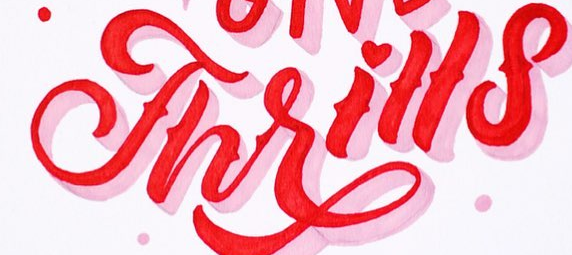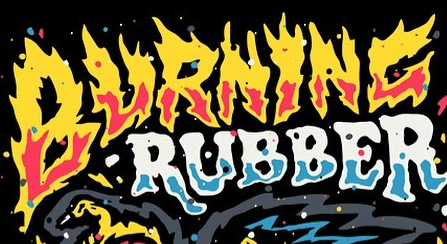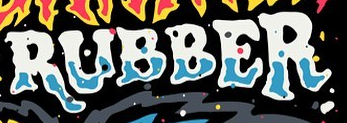Transcribe the words shown in these images in order, separated by a semicolon. Thrills; BURNINC; RUBBER 